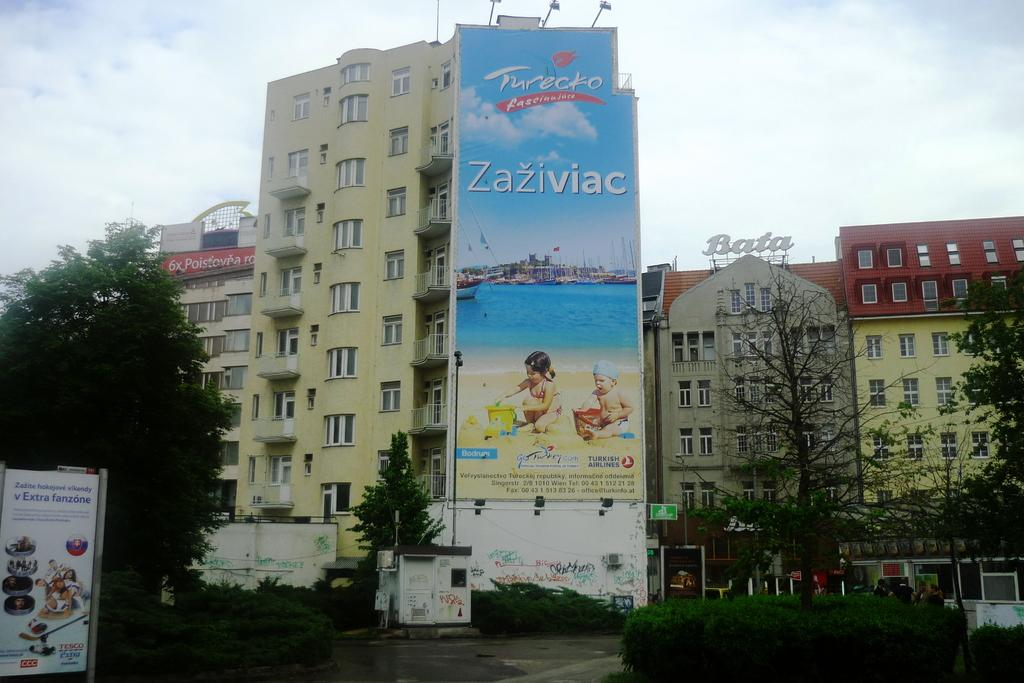<image>
Offer a succinct explanation of the picture presented. A vertical Turecko advertising poster hangs from the side of a building. 